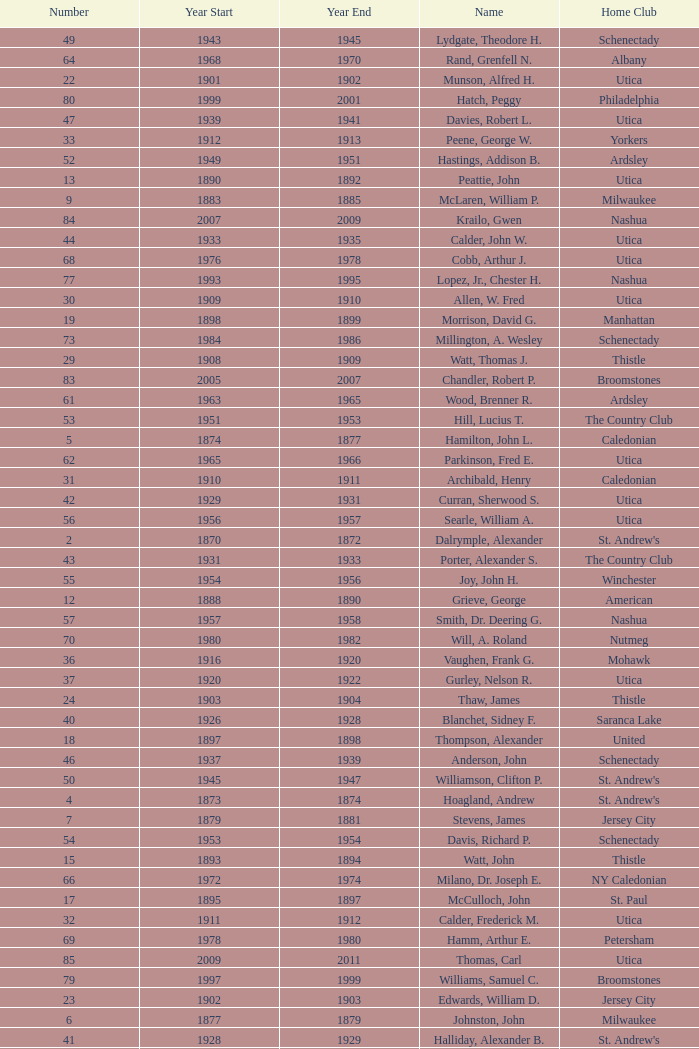Which Number has a Name of cooper, c. kenneth, and a Year End larger than 1984? None. 